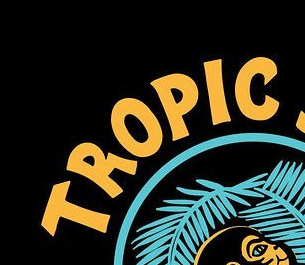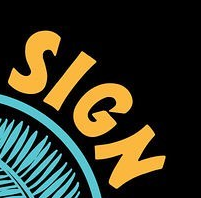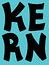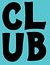Read the text content from these images in order, separated by a semicolon. TROPLC; SIGN; KERN; CLUB 